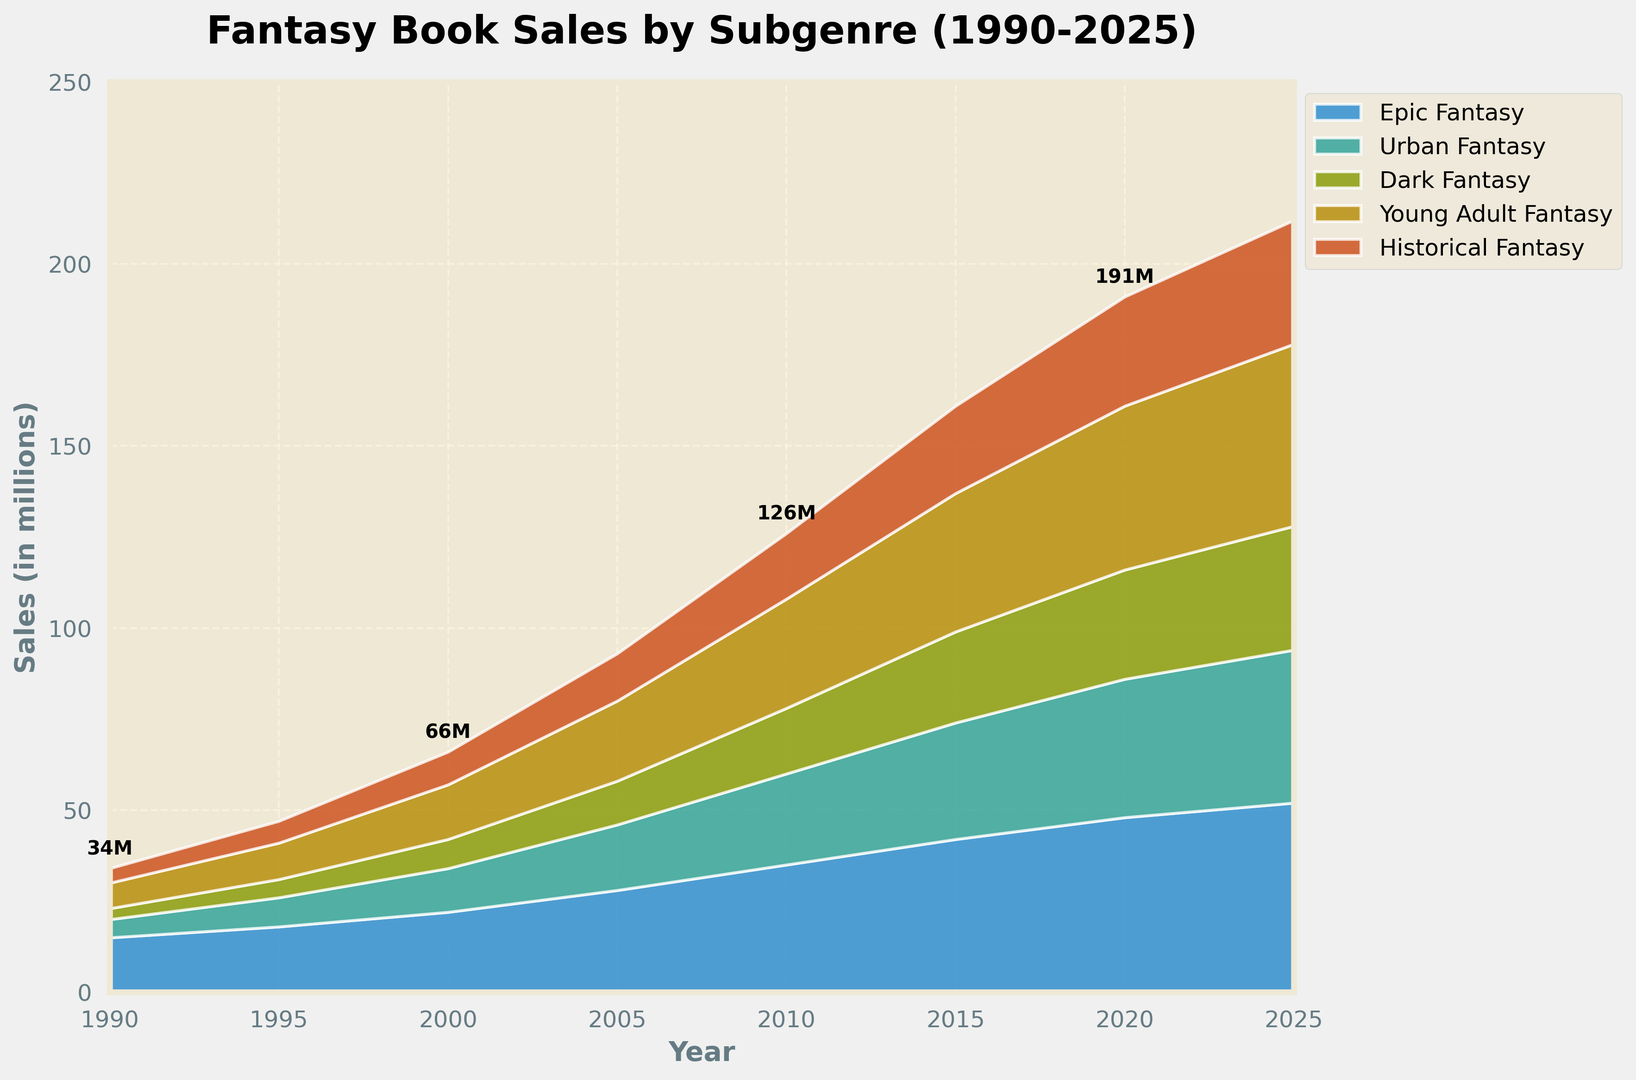What subgenre had the highest sales in 2025? To identify the subgenre with the highest sales in 2025, we need to look at the endpoint on the area chart for each subgenre and compare their heights. Epic Fantasy has the highest endpoint value.
Answer: Epic Fantasy By how much did Young Adult Fantasy sales increase from 1990 to 2025? To find the increase, subtract the 1990 sales of Young Adult Fantasy from the 2025 sales: 50 - 7 = 43 million.
Answer: 43 million Which subgenre saw the most significant increase in sales between 2010 and 2020? To determine this, calculate the difference in sales for each subgenre between 2010 and 2020, then compare the results. Epic Fantasy increased by 48-35 = 13 million, Urban Fantasy by 38-25 = 13 million, Dark Fantasy by 30-18 = 12 million, Young Adult Fantasy by 45-30 = 15 million, and Historical Fantasy by 30-18 = 12 million. So, Young Adult Fantasy had the most significant increase.
Answer: Young Adult Fantasy What is the total sales for all subgenres combined in the year 2000? Add the sales for each subgenre in the year 2000: 22 (Epic Fantasy) + 12 (Urban Fantasy) + 8 (Dark Fantasy) + 15 (Young Adult Fantasy) + 9 (Historical Fantasy) = 66 million.
Answer: 66 million How did the sales of Urban Fantasy in 2015 compare to those in 1995? Subtract Urban Fantasy sales in 1995 from those in 2015: 32 - 8 = 24 million increase.
Answer: Increased by 24 million Which subgenre showed a steady increase in sales over the decades? Reviewing the trends for each subgenre shows that Epic Fantasy, Urban Fantasy, Young Adult Fantasy, and Historical Fantasy all display continuous rise; thus, we focus on only one subgenre for the answer after examining the incremental increase visually and line patterns. Epic Fantasy is the most distinct for a steady increase.
Answer: Epic Fantasy What were the total sales for all subgenres in 2010, and how does it compare to the total sales in 2005? Calculate the total for 2010: 35+25+18+30+18=126 million, and for 2005: 28+18+12+22+13=93 million. Then subtract 93 from 126 to find the difference: 126 - 93 = 33 million more in 2010 than 2005.
Answer: 33 million more Compared to Historical Fantasy, how have the sales of Dark Fantasy evolved from 1990 to 2025? Look at the sales of both subgenres over the years: Dark Fantasy sales increased from 3 to 34 million, while Historical Fantasy grew from 4 to 34 million. Both subgenres reached 34 million in 2025, with Dark Fantasy starting at a lower value and growing at a more rapid pace.
Answer: Increased more rapidly 